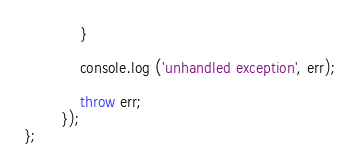Convert code to text. <code><loc_0><loc_0><loc_500><loc_500><_JavaScript_>			}

			console.log ('unhandled exception', err);

			throw err;
		});
};
</code> 